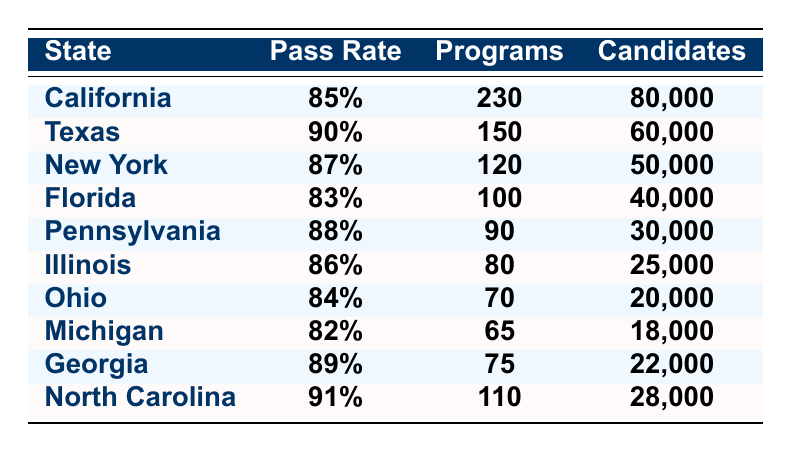What is the pass rate for North Carolina? The table indicates that North Carolina has a pass rate of 91%.
Answer: 91% Which state had the lowest pass rate? By comparing the pass rates listed, Michigan has the lowest pass rate at 82%.
Answer: Michigan How many candidates were tested in California? According to the table, California had 80,000 candidates tested.
Answer: 80,000 What is the average pass rate of the states listed? The pass rates are: 85%, 90%, 87%, 83%, 88%, 86%, 84%, 82%, 89%, and 91%. The sum is  85 + 90 + 87 + 83 + 88 + 86 + 84 + 82 + 89 + 91 =  10 and the average is 874/10 = 87.4%.
Answer: 87.4% Is it true that Texas has more approved nursing programs than Florida? Texas has 150 approved nursing programs, while Florida has 100, so the statement is true.
Answer: Yes How many more candidates were tested in Texas compared to Illinois? Texas had 60,000 candidates tested and Illinois had 25,000. The difference is 60,000 - 25,000 = 35,000.
Answer: 35,000 Which state has a pass rate that is 4% higher than California? California's pass rate is 85%, and a 4% increase would be 89%. Georgia has a pass rate of 89%, which is 4% higher than California.
Answer: Georgia If we consider only those states with a pass rate above 85%, how many candidates were tested in total? The states with a pass rate above 85% are Texas, New York, Pennsylvania, Illinois, Georgia, and North Carolina. The total number of candidates tested is 60,000 (Texas) + 50,000 (New York) + 30,000 (Pennsylvania) + 25,000 (Illinois) + 22,000 (Georgia) + 28,000 (North Carolina) = 215,000.
Answer: 215,000 Which two states have a pass rate closer to the average of 87.4%? The states closest to the average of 87.4% are New York at 87% and Pennsylvania at 88%.
Answer: New York and Pennsylvania What percentage of candidates tested in Florida passed the exam? Florida had a pass rate of 83%, meaning 83% of the 40,000 candidates tested passed the exam.
Answer: 83% 